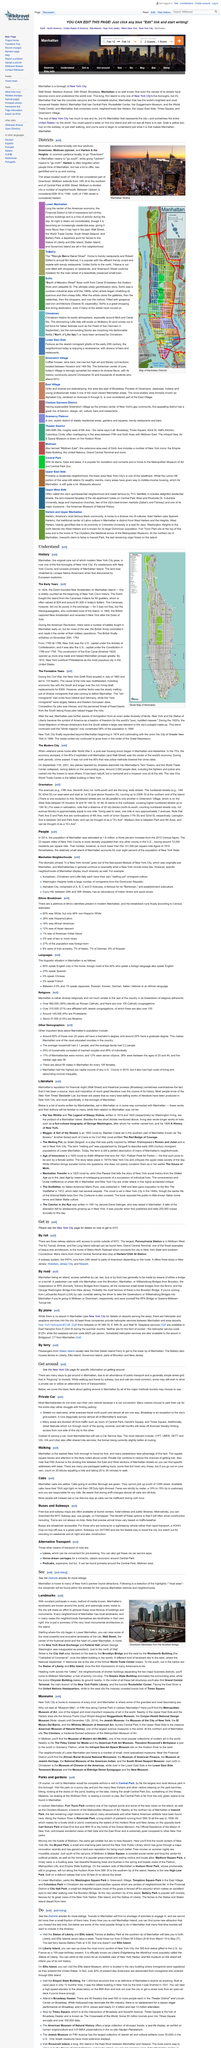Highlight a few significant elements in this photo. The above picture showcases the Manhattan skyline, which is a prominent feature in the background. The Dutch paid a total of 60 guilders to the Canarsee Indians for the acquisition of Manhattan Island, which is equivalent to approximately $24 and $1000 in today's currency. The most common ways to get around in Manhattan are walking and traveling by subway. It is important to note that if a person does not have access to the internet or mobile apps, they may not be able to determine bus routes and schedules. Fortunately, free bus and subway maps are often available at tourist centers and hotel lobbies, providing individuals with the information they need to plan their journey. Manhattan is divided into four distinct sections, each with its own unique character and attractions. 